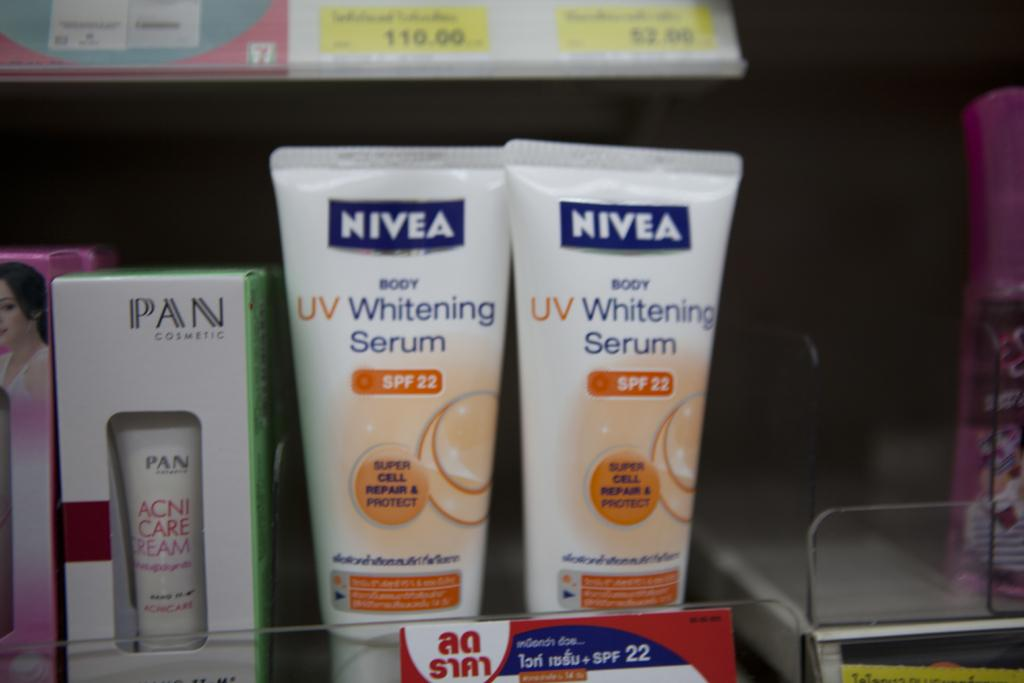<image>
Provide a brief description of the given image. A display of Nivea UV Whitening Serum sits on a shelf. 